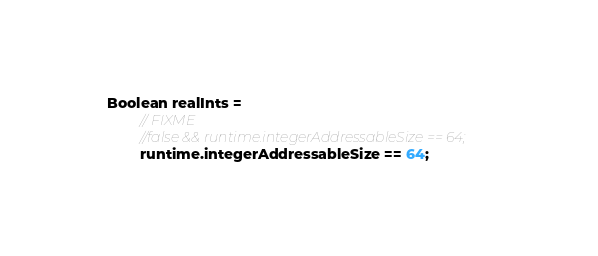Convert code to text. <code><loc_0><loc_0><loc_500><loc_500><_Ceylon_>Boolean realInts =
        // FIXME
        //false && runtime.integerAddressableSize == 64;
        runtime.integerAddressableSize == 64;
</code> 